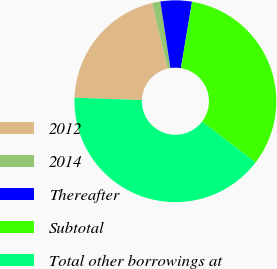<chart> <loc_0><loc_0><loc_500><loc_500><pie_chart><fcel>2012<fcel>2014<fcel>Thereafter<fcel>Subtotal<fcel>Total other borrowings at<nl><fcel>20.77%<fcel>1.31%<fcel>5.02%<fcel>32.74%<fcel>40.17%<nl></chart> 